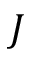<formula> <loc_0><loc_0><loc_500><loc_500>J</formula> 